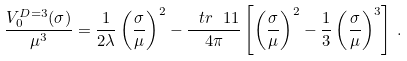<formula> <loc_0><loc_0><loc_500><loc_500>\frac { V _ { 0 } ^ { D = 3 } ( \sigma ) } { \mu ^ { 3 } } = \frac { 1 } { 2 \lambda } \left ( \frac { \sigma } { \mu } \right ) ^ { 2 } - \frac { \ t r \ 1 1 } { 4 \pi } \left [ \left ( \frac { \sigma } { \mu } \right ) ^ { 2 } - \frac { 1 } { 3 } \left ( \frac { \sigma } { \mu } \right ) ^ { 3 } \right ] \, .</formula> 